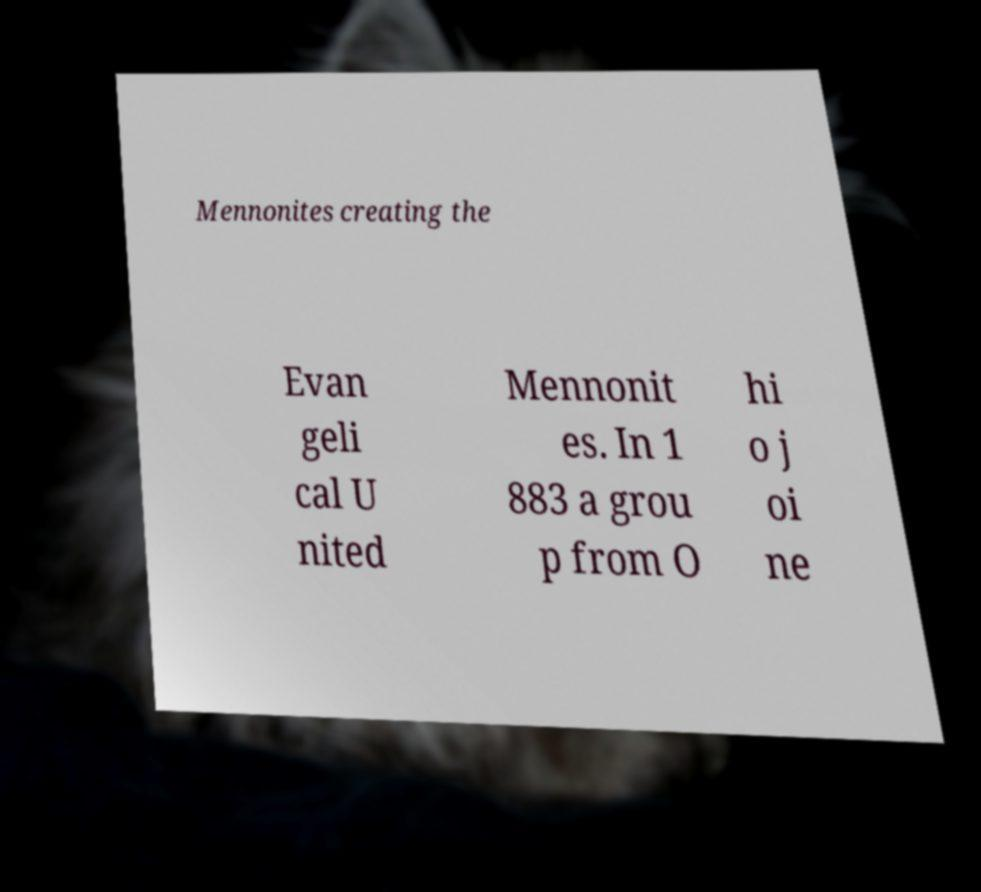Please identify and transcribe the text found in this image. Mennonites creating the Evan geli cal U nited Mennonit es. In 1 883 a grou p from O hi o j oi ne 